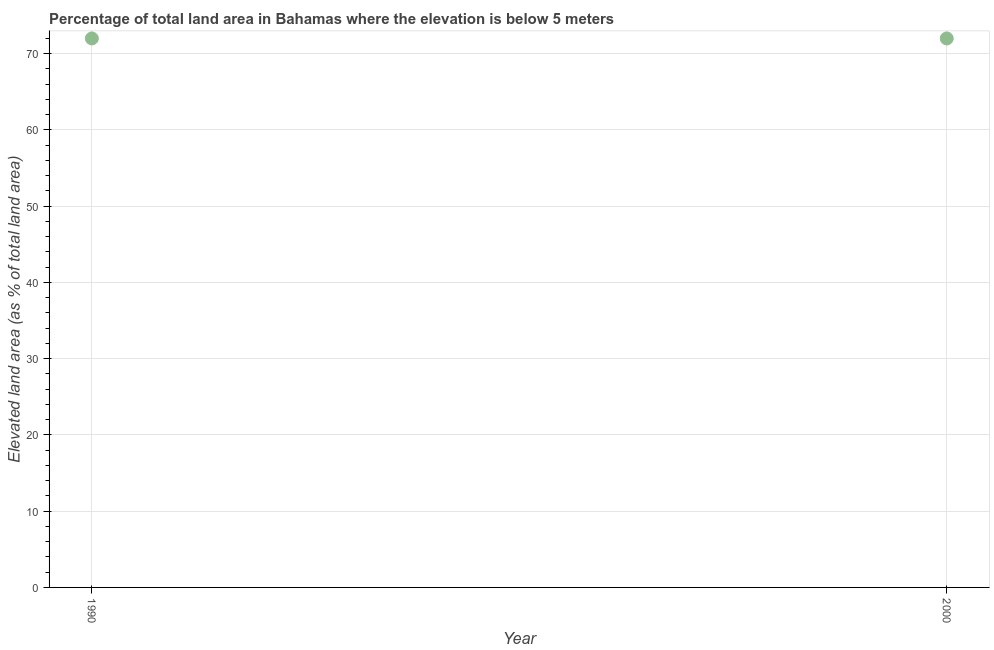What is the total elevated land area in 1990?
Provide a succinct answer. 71.99. Across all years, what is the maximum total elevated land area?
Offer a very short reply. 71.99. Across all years, what is the minimum total elevated land area?
Give a very brief answer. 71.99. In which year was the total elevated land area minimum?
Make the answer very short. 1990. What is the sum of the total elevated land area?
Offer a terse response. 143.97. What is the difference between the total elevated land area in 1990 and 2000?
Provide a short and direct response. 0. What is the average total elevated land area per year?
Your response must be concise. 71.99. What is the median total elevated land area?
Your response must be concise. 71.99. In how many years, is the total elevated land area greater than 26 %?
Your answer should be very brief. 2. What is the ratio of the total elevated land area in 1990 to that in 2000?
Ensure brevity in your answer.  1. Is the total elevated land area in 1990 less than that in 2000?
Offer a terse response. No. How many dotlines are there?
Provide a short and direct response. 1. What is the difference between two consecutive major ticks on the Y-axis?
Make the answer very short. 10. What is the title of the graph?
Provide a short and direct response. Percentage of total land area in Bahamas where the elevation is below 5 meters. What is the label or title of the Y-axis?
Provide a succinct answer. Elevated land area (as % of total land area). What is the Elevated land area (as % of total land area) in 1990?
Offer a very short reply. 71.99. What is the Elevated land area (as % of total land area) in 2000?
Offer a terse response. 71.99. 